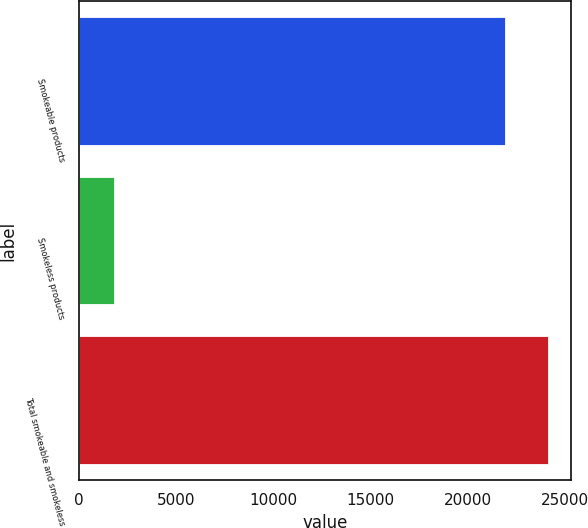Convert chart. <chart><loc_0><loc_0><loc_500><loc_500><bar_chart><fcel>Smokeable products<fcel>Smokeless products<fcel>Total smokeable and smokeless<nl><fcel>21939<fcel>1809<fcel>24132.9<nl></chart> 